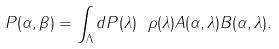Convert formula to latex. <formula><loc_0><loc_0><loc_500><loc_500>P ( \alpha , \beta ) = \int _ { \Lambda } d P ( \lambda ) \ \rho ( \lambda ) A ( \alpha , \lambda ) B ( \alpha , \lambda ) .</formula> 